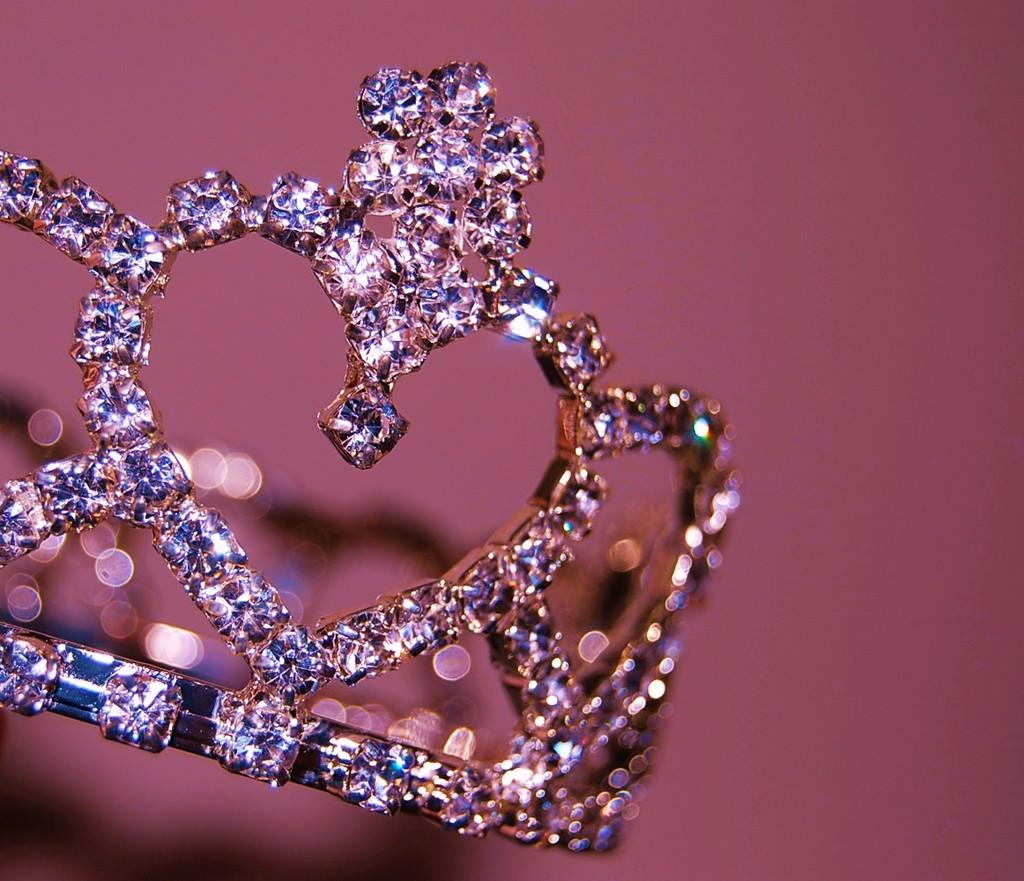What is the main object in the image? There is a crown in the image. Can you describe the background of the image? The background of the image is blurred. What caption is written on the crown in the image? There is no caption written on the crown in the image. Can you tell me how much the receipt costs in the image? There is no receipt present in the image. 